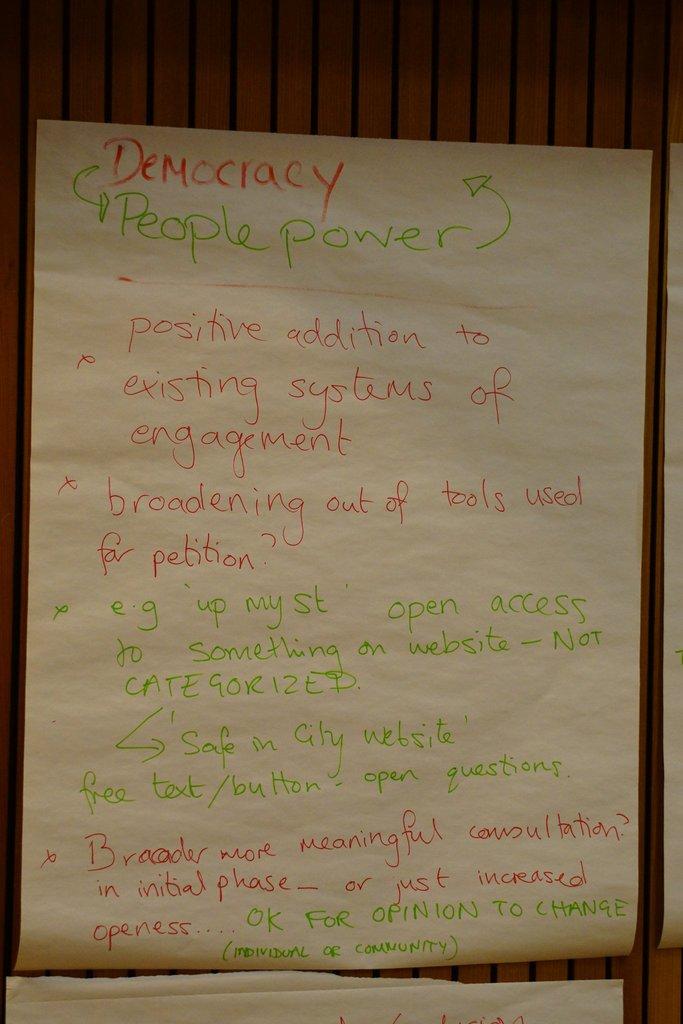What is the form of government named on the paper?
Provide a short and direct response. Democracy. People over what?
Keep it short and to the point. Unanswerable. 